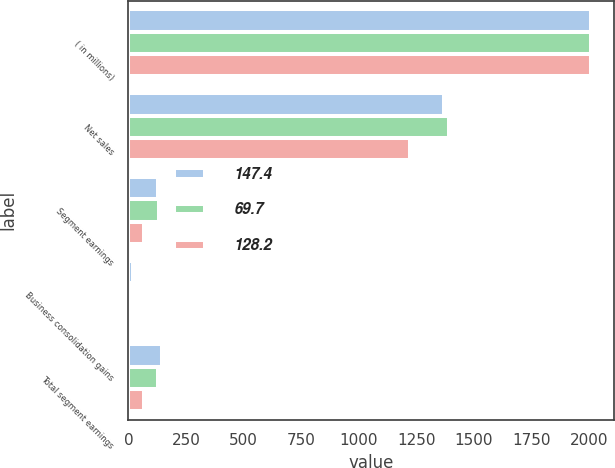Convert chart to OTSL. <chart><loc_0><loc_0><loc_500><loc_500><stacked_bar_chart><ecel><fcel>( in millions)<fcel>Net sales<fcel>Segment earnings<fcel>Business consolidation gains<fcel>Total segment earnings<nl><fcel>147.4<fcel>2010<fcel>1370.1<fcel>129.1<fcel>18.3<fcel>147.4<nl><fcel>69.7<fcel>2009<fcel>1392.9<fcel>130.8<fcel>2.6<fcel>128.2<nl><fcel>128.2<fcel>2008<fcel>1221.4<fcel>68.1<fcel>1.6<fcel>69.7<nl></chart> 